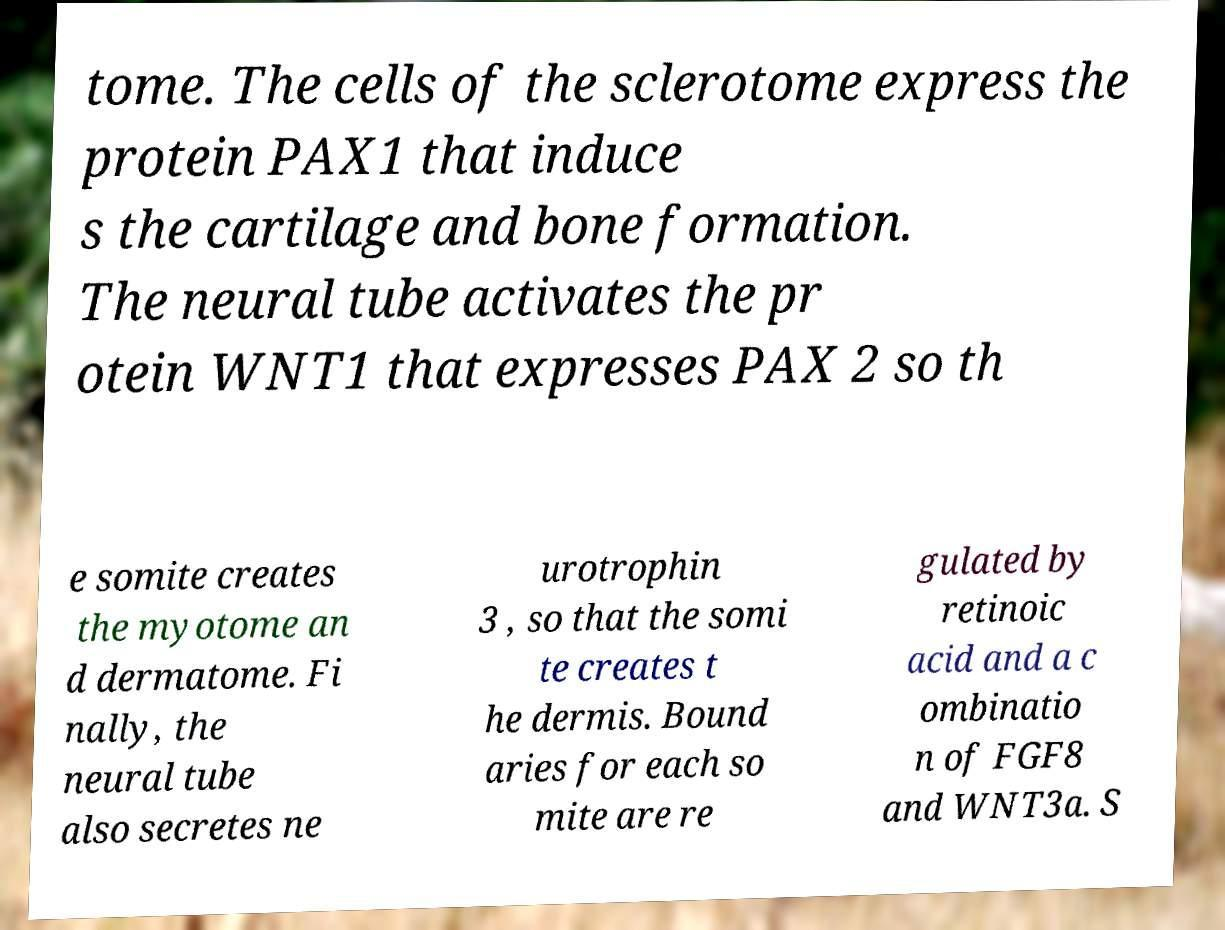Can you accurately transcribe the text from the provided image for me? tome. The cells of the sclerotome express the protein PAX1 that induce s the cartilage and bone formation. The neural tube activates the pr otein WNT1 that expresses PAX 2 so th e somite creates the myotome an d dermatome. Fi nally, the neural tube also secretes ne urotrophin 3 , so that the somi te creates t he dermis. Bound aries for each so mite are re gulated by retinoic acid and a c ombinatio n of FGF8 and WNT3a. S 